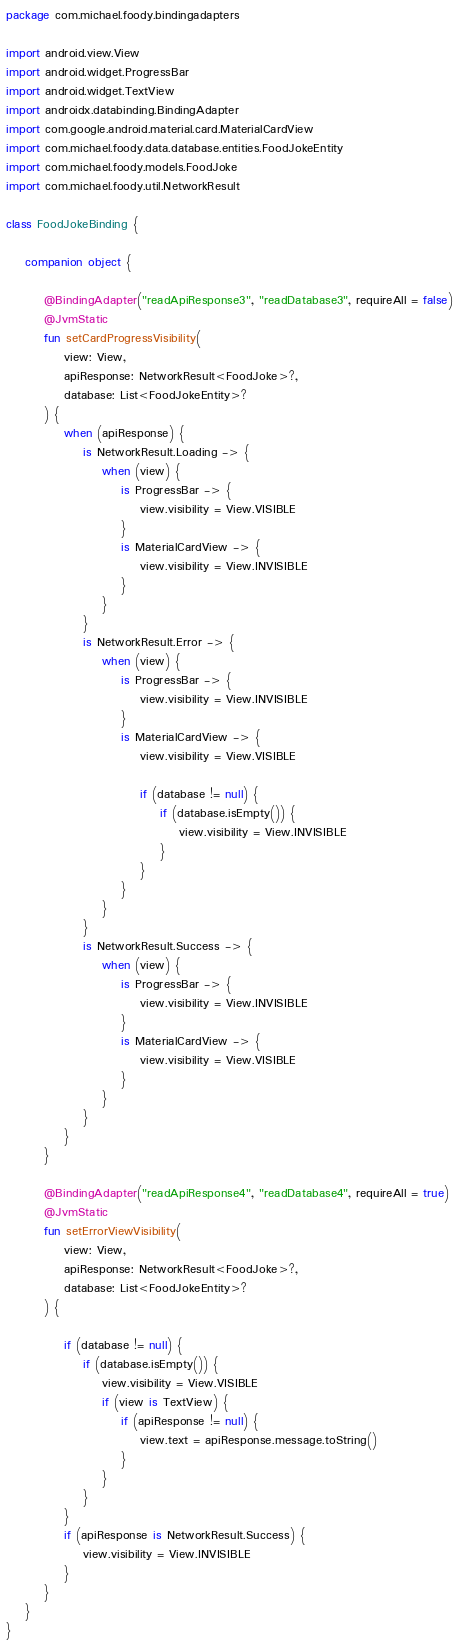<code> <loc_0><loc_0><loc_500><loc_500><_Kotlin_>package com.michael.foody.bindingadapters

import android.view.View
import android.widget.ProgressBar
import android.widget.TextView
import androidx.databinding.BindingAdapter
import com.google.android.material.card.MaterialCardView
import com.michael.foody.data.database.entities.FoodJokeEntity
import com.michael.foody.models.FoodJoke
import com.michael.foody.util.NetworkResult

class FoodJokeBinding {

    companion object {

        @BindingAdapter("readApiResponse3", "readDatabase3", requireAll = false)
        @JvmStatic
        fun setCardProgressVisibility(
            view: View,
            apiResponse: NetworkResult<FoodJoke>?,
            database: List<FoodJokeEntity>?
        ) {
            when (apiResponse) {
                is NetworkResult.Loading -> {
                    when (view) {
                        is ProgressBar -> {
                            view.visibility = View.VISIBLE
                        }
                        is MaterialCardView -> {
                            view.visibility = View.INVISIBLE
                        }
                    }
                }
                is NetworkResult.Error -> {
                    when (view) {
                        is ProgressBar -> {
                            view.visibility = View.INVISIBLE
                        }
                        is MaterialCardView -> {
                            view.visibility = View.VISIBLE

                            if (database != null) {
                                if (database.isEmpty()) {
                                    view.visibility = View.INVISIBLE
                                }
                            }
                        }
                    }
                }
                is NetworkResult.Success -> {
                    when (view) {
                        is ProgressBar -> {
                            view.visibility = View.INVISIBLE
                        }
                        is MaterialCardView -> {
                            view.visibility = View.VISIBLE
                        }
                    }
                }
            }
        }

        @BindingAdapter("readApiResponse4", "readDatabase4", requireAll = true)
        @JvmStatic
        fun setErrorViewVisibility(
            view: View,
            apiResponse: NetworkResult<FoodJoke>?,
            database: List<FoodJokeEntity>?
        ) {

            if (database != null) {
                if (database.isEmpty()) {
                    view.visibility = View.VISIBLE
                    if (view is TextView) {
                        if (apiResponse != null) {
                            view.text = apiResponse.message.toString()
                        }
                    }
                }
            }
            if (apiResponse is NetworkResult.Success) {
                view.visibility = View.INVISIBLE
            }
        }
    }
}</code> 